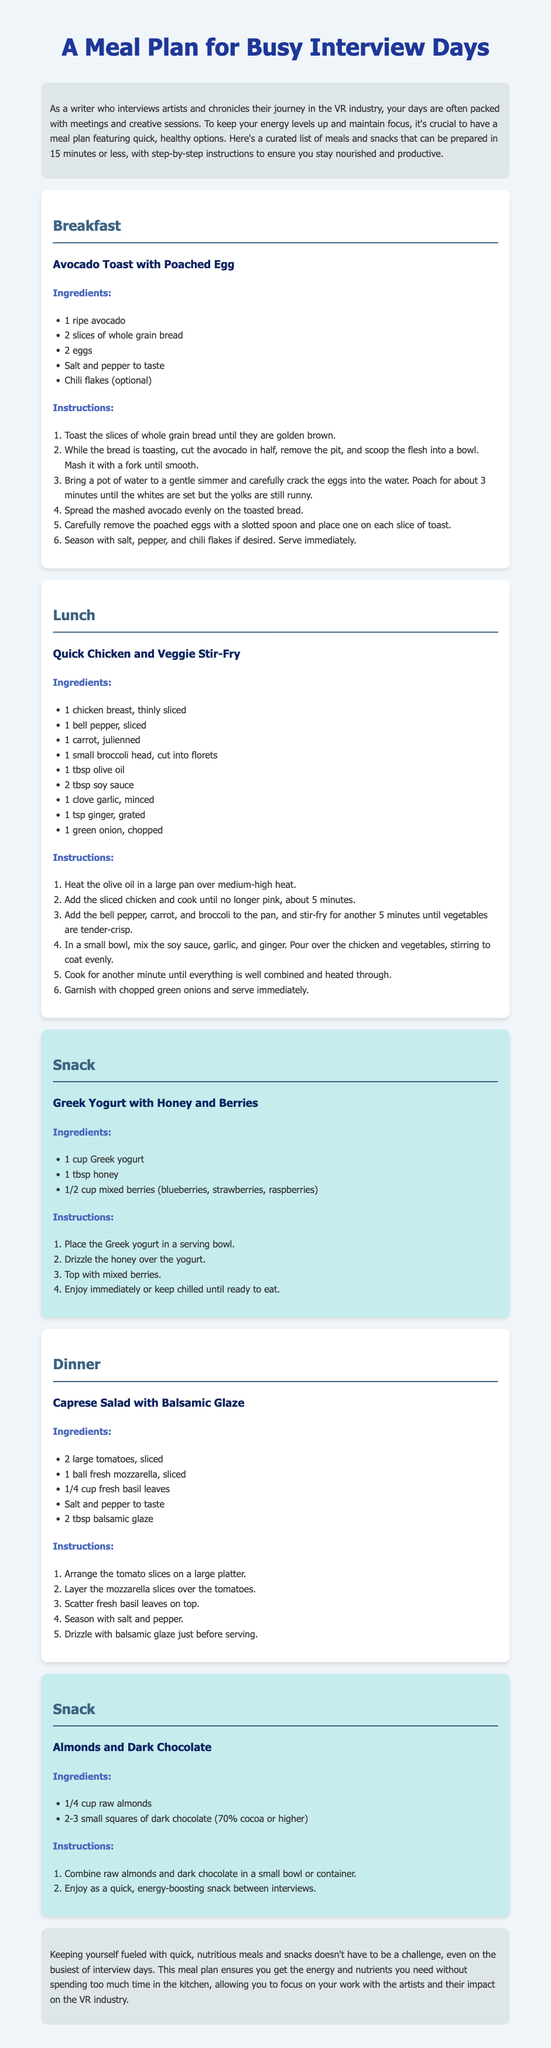What is the title of the meal plan? The title is displayed prominently at the top of the document.
Answer: A Meal Plan for Busy Interview Days How long does it take to prepare the meals? The document specifies that meals can be prepared in 15 minutes or less.
Answer: 15 minutes What are the ingredients for the Avocado Toast? The ingredients for the Avocado Toast are listed in a section dedicated to that meal.
Answer: 1 ripe avocado, 2 slices of whole grain bread, 2 eggs, salt, pepper, chili flakes What is the main protein source in the Chicken and Veggie Stir-Fry? The main protein source is identified in the list of ingredients for that meal.
Answer: Chicken breast How many types of meals are included in the plan? The document outlines breakfast, lunch, dinner, and snacks which can be counted.
Answer: 4 types of meals What's an example of a snack provided in the meal plan? The document includes specific snack options which can be named.
Answer: Greek Yogurt with Honey and Berries What is used to drizzle over the Caprese Salad? The document provides a specific ingredient used for this purpose in the Caprese salad recipe.
Answer: Balsamic glaze Which meal includes a poached egg? The meal associated with a poached egg is explicitly named in the document.
Answer: Avocado Toast with Poached Egg 